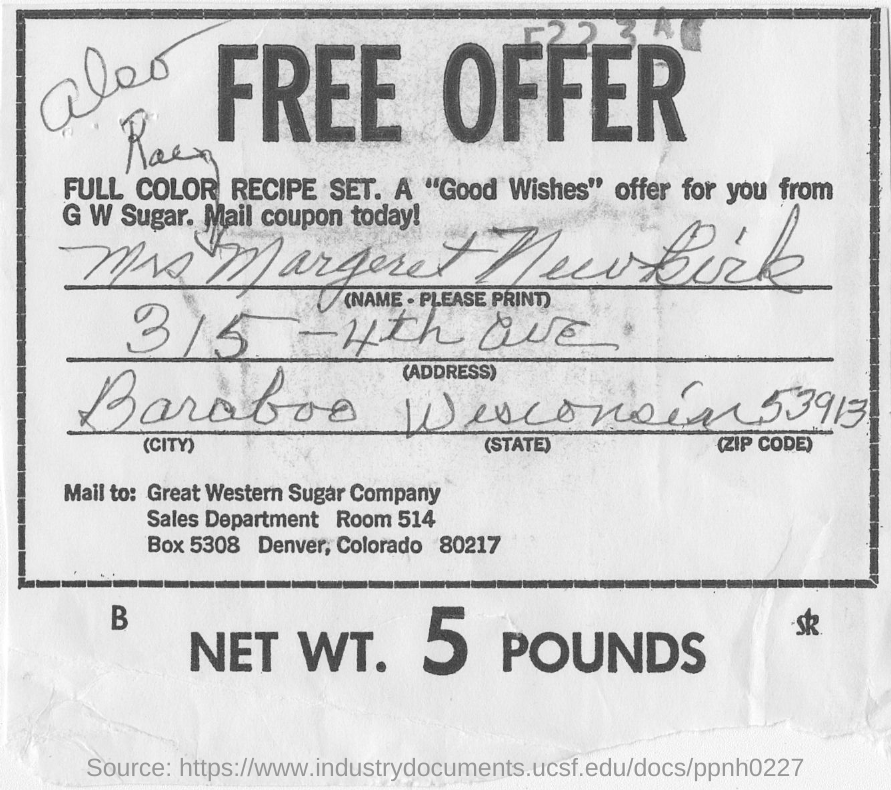Outline some significant characteristics in this image. The NET WT. is 5 POUNDS. The zip code for Colorado is 80217. 